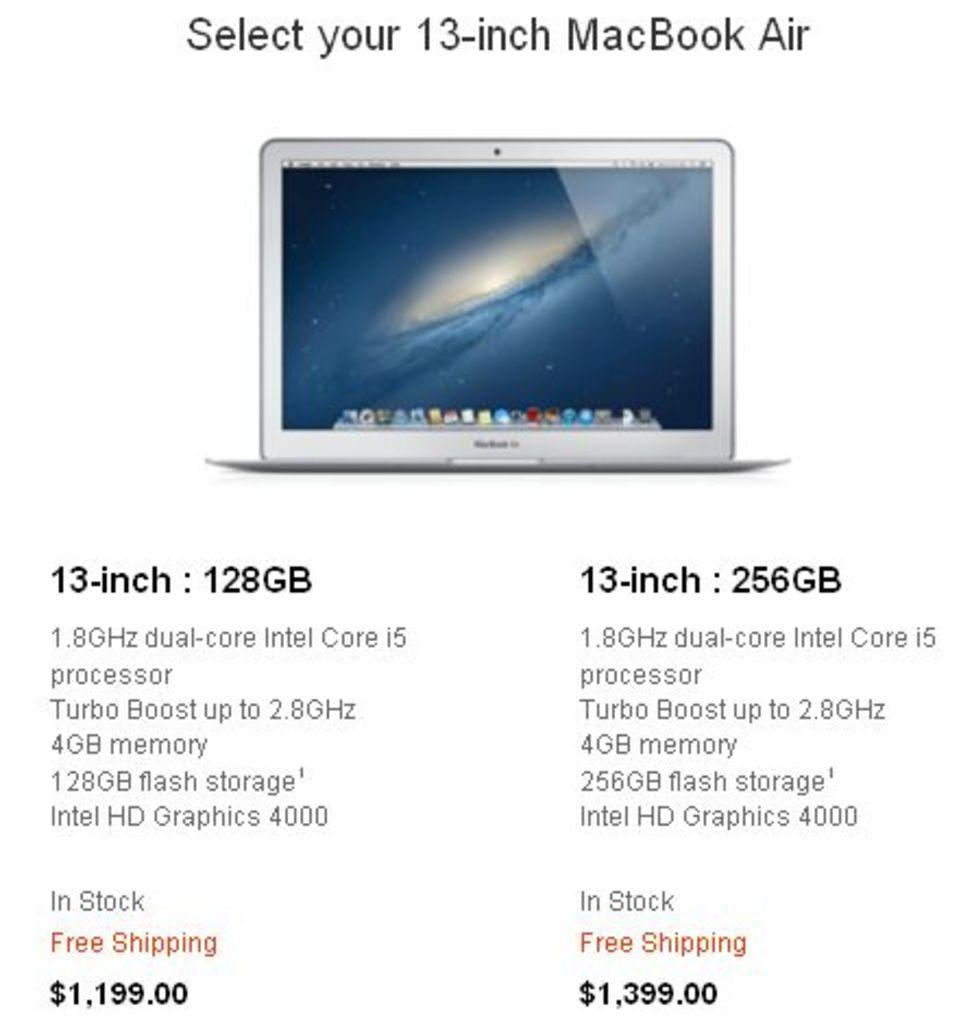Provide a one-sentence caption for the provided image. Details regarding a 13-inch MacBook Air which includes 4gb memory. 